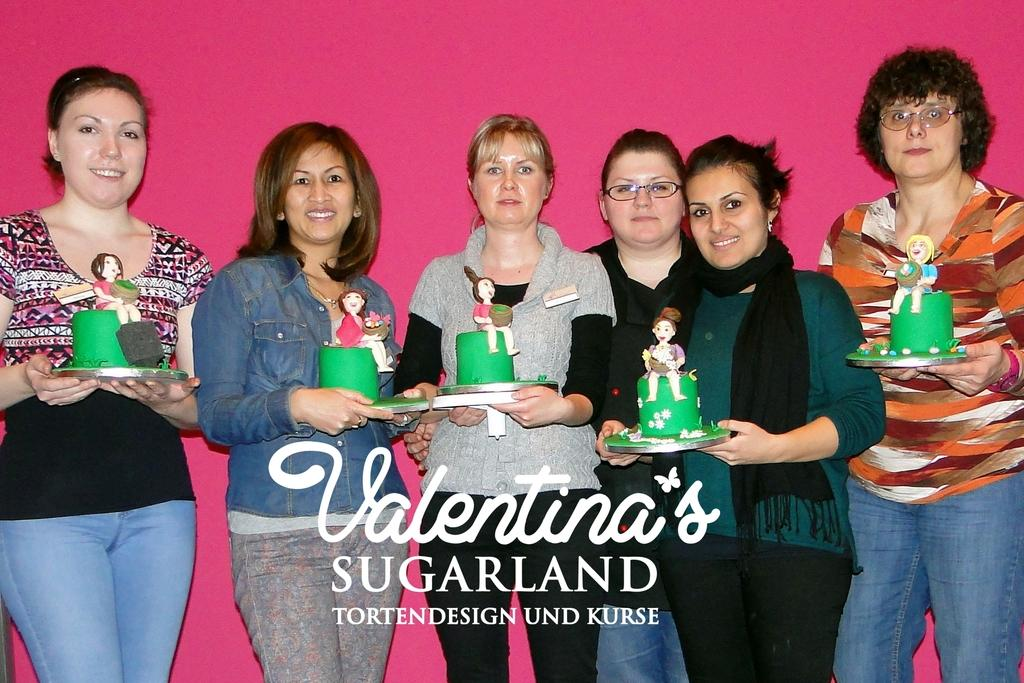Who or what is present in the image? There are people in the image. What are the people wearing? The people are wearing clothes. What are the people doing with their hands? The people are holding objects with their hands. What can be found at the bottom of the image? There is text at the bottom of the image. Is there any blood visible on the people or objects in the image? There is no indication of blood in the image. What type of spoon can be seen in the image? There is no spoon present in the image. 